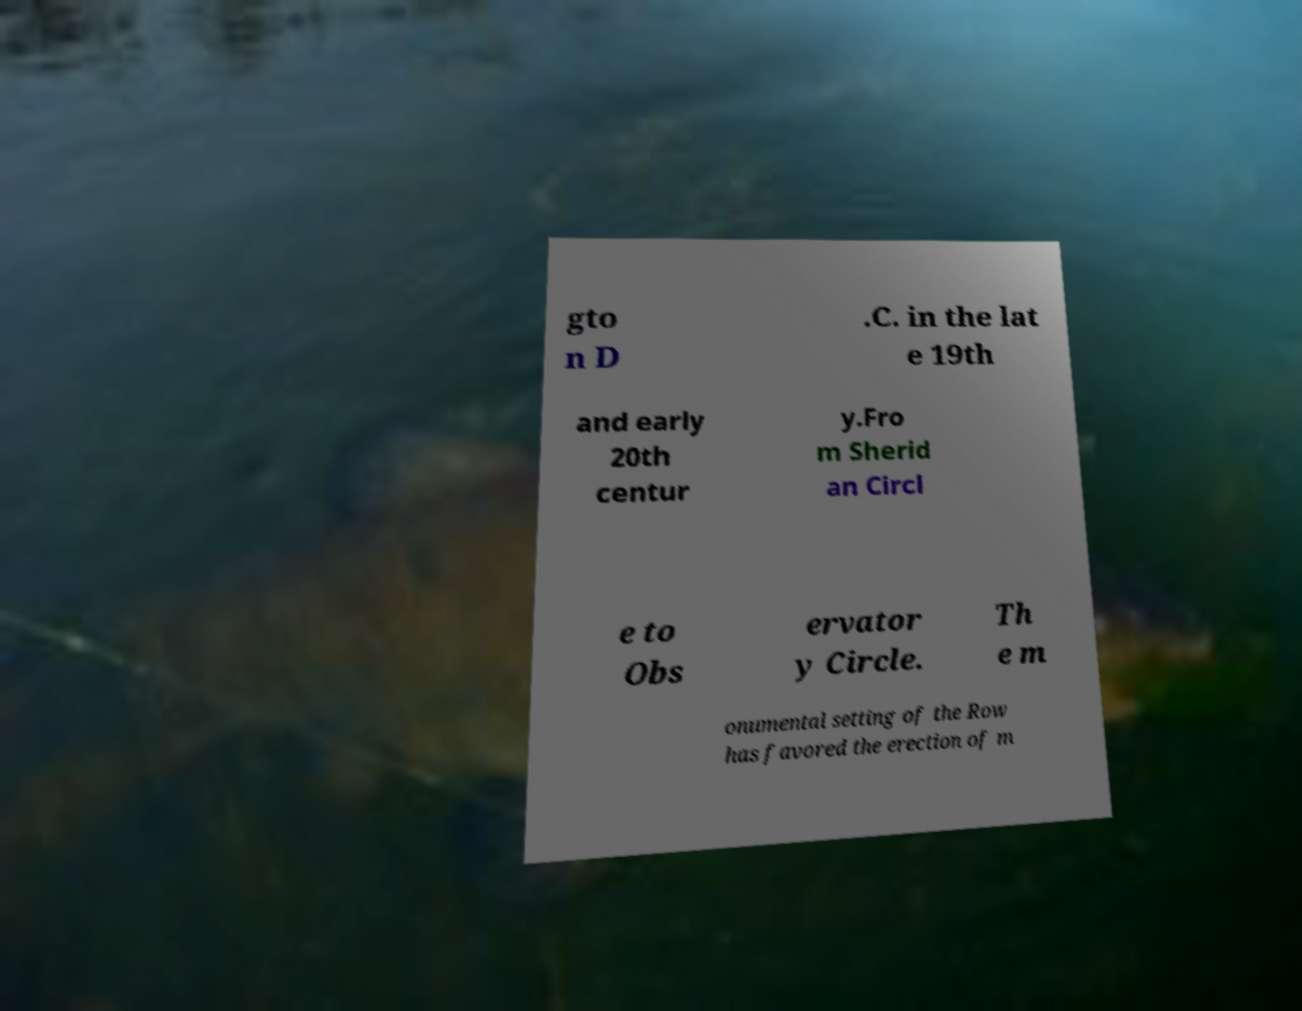Could you extract and type out the text from this image? gto n D .C. in the lat e 19th and early 20th centur y.Fro m Sherid an Circl e to Obs ervator y Circle. Th e m onumental setting of the Row has favored the erection of m 